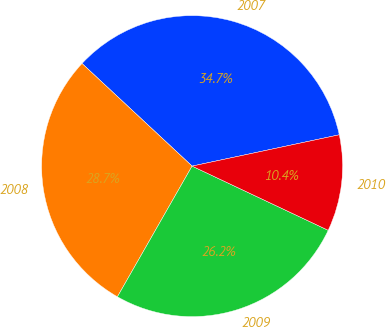Convert chart to OTSL. <chart><loc_0><loc_0><loc_500><loc_500><pie_chart><fcel>2007<fcel>2008<fcel>2009<fcel>2010<nl><fcel>34.72%<fcel>28.68%<fcel>26.25%<fcel>10.35%<nl></chart> 